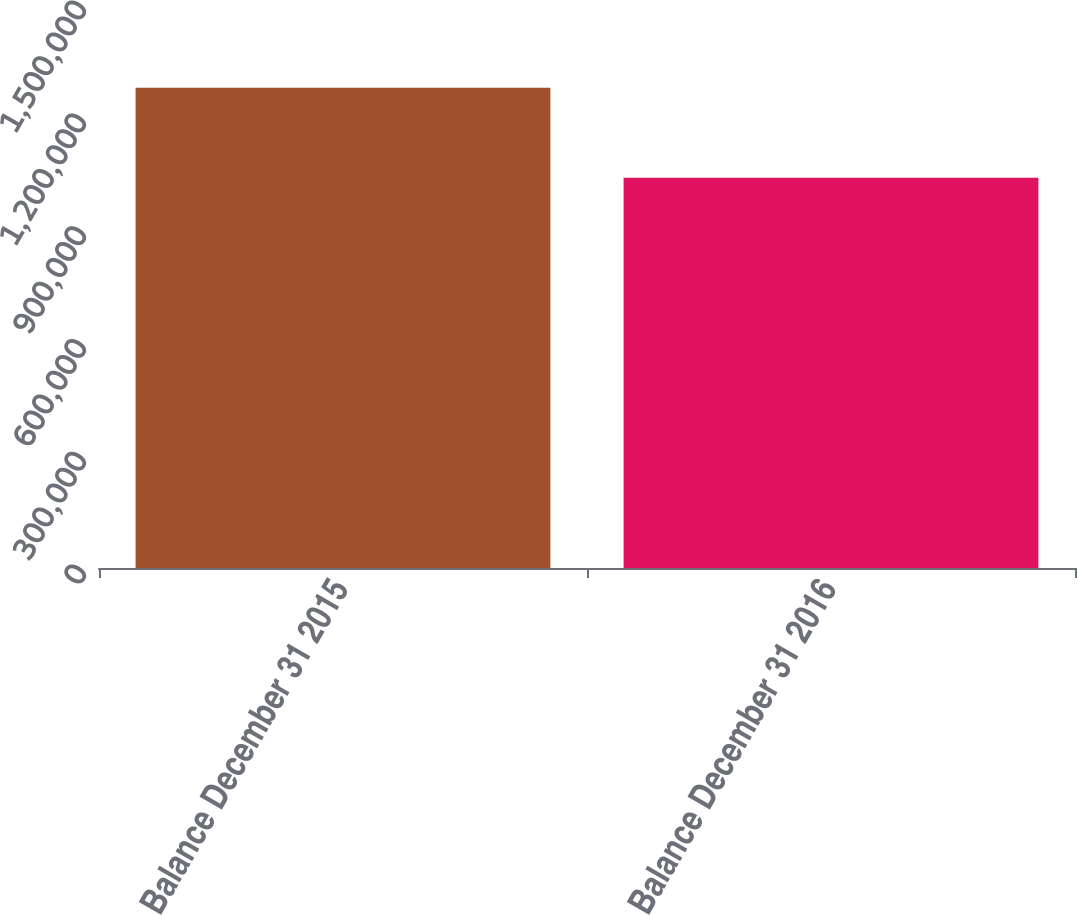<chart> <loc_0><loc_0><loc_500><loc_500><bar_chart><fcel>Balance December 31 2015<fcel>Balance December 31 2016<nl><fcel>1.27695e+06<fcel>1.03806e+06<nl></chart> 